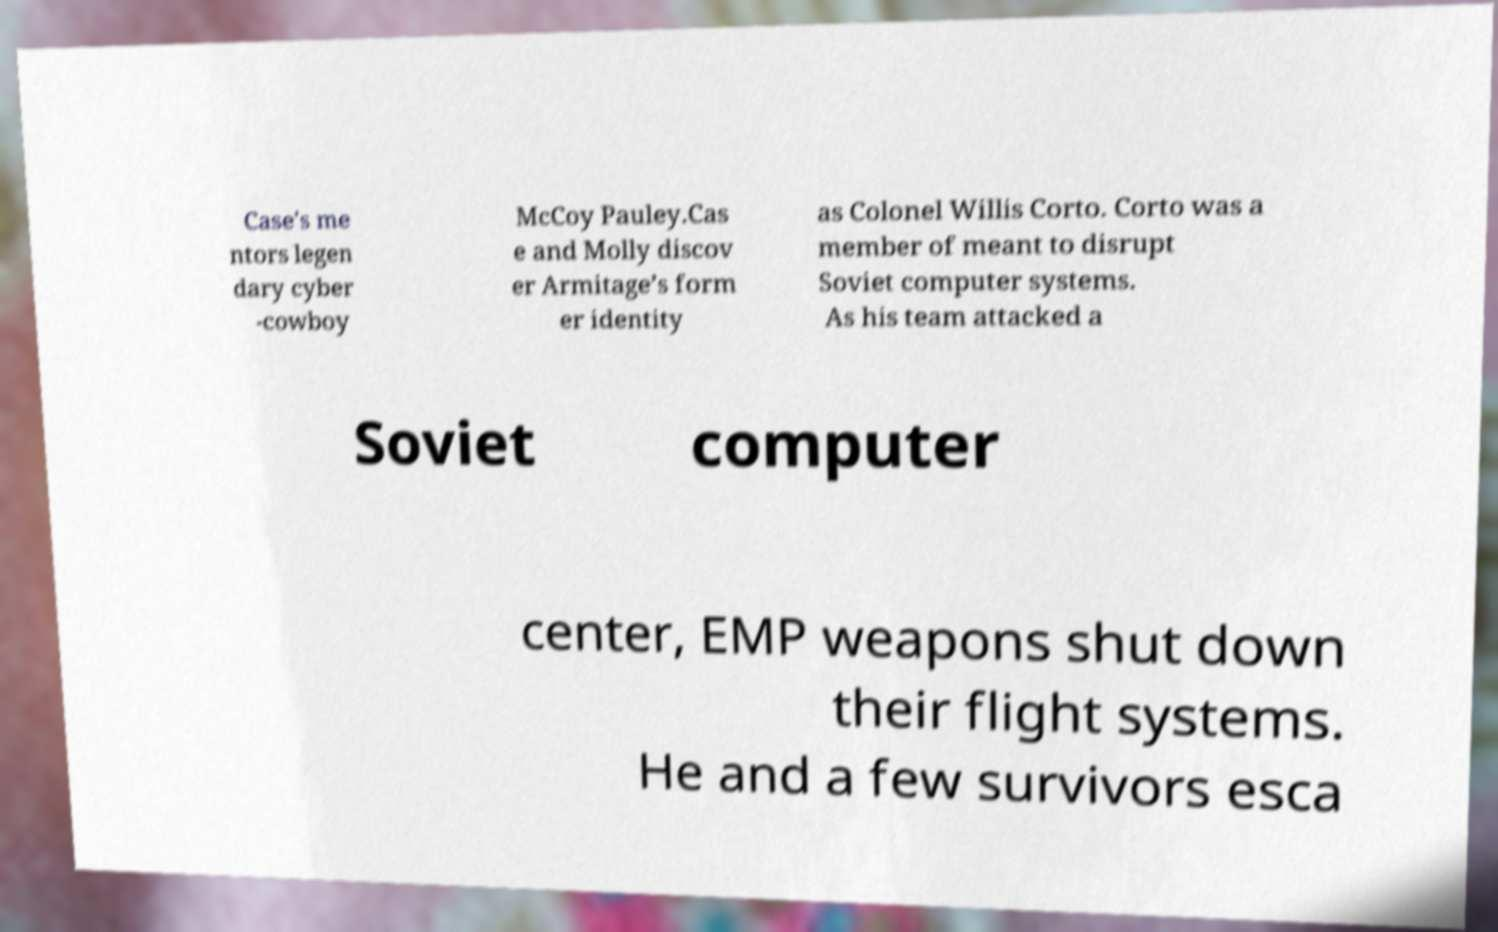What messages or text are displayed in this image? I need them in a readable, typed format. Case's me ntors legen dary cyber -cowboy McCoy Pauley.Cas e and Molly discov er Armitage’s form er identity as Colonel Willis Corto. Corto was a member of meant to disrupt Soviet computer systems. As his team attacked a Soviet computer center, EMP weapons shut down their flight systems. He and a few survivors esca 